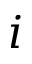Convert formula to latex. <formula><loc_0><loc_0><loc_500><loc_500>i</formula> 